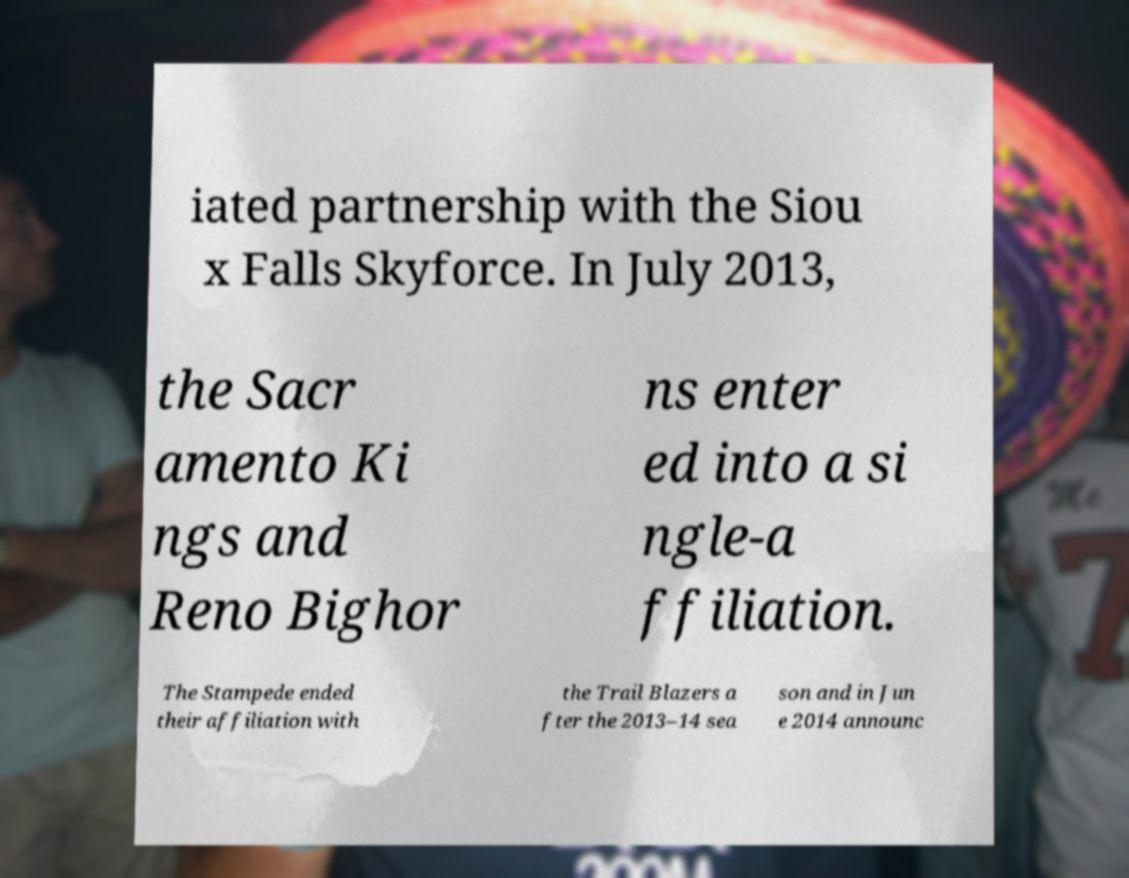Can you read and provide the text displayed in the image?This photo seems to have some interesting text. Can you extract and type it out for me? iated partnership with the Siou x Falls Skyforce. In July 2013, the Sacr amento Ki ngs and Reno Bighor ns enter ed into a si ngle-a ffiliation. The Stampede ended their affiliation with the Trail Blazers a fter the 2013–14 sea son and in Jun e 2014 announc 